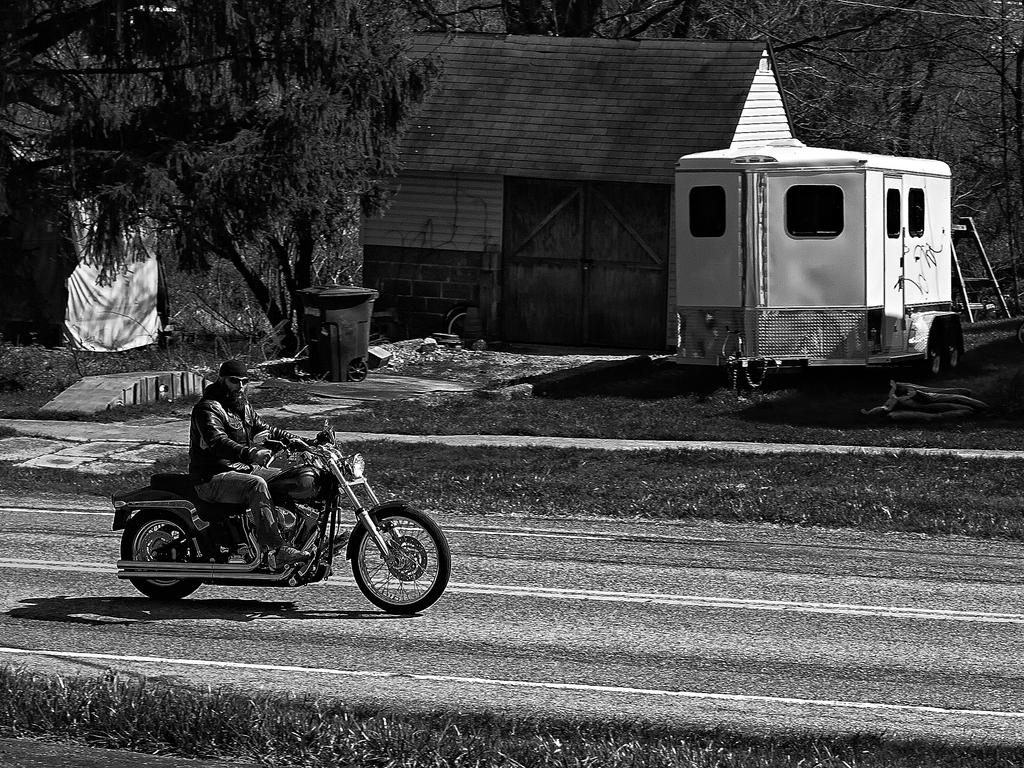What is the person in the image riding? The person is on a motorbike in the image. Where is the motorbike located? The motorbike is on the road in the image. What can be seen in the background of the image? There are trees visible in the image, and a house can be seen in the distance. What type of lumber is being used to construct the motorbike in the image? There is no mention of lumber or any construction materials in the image; it features a person riding a motorbike on the road. Are there any bears visible in the image? No, there are no bears present in the image. 